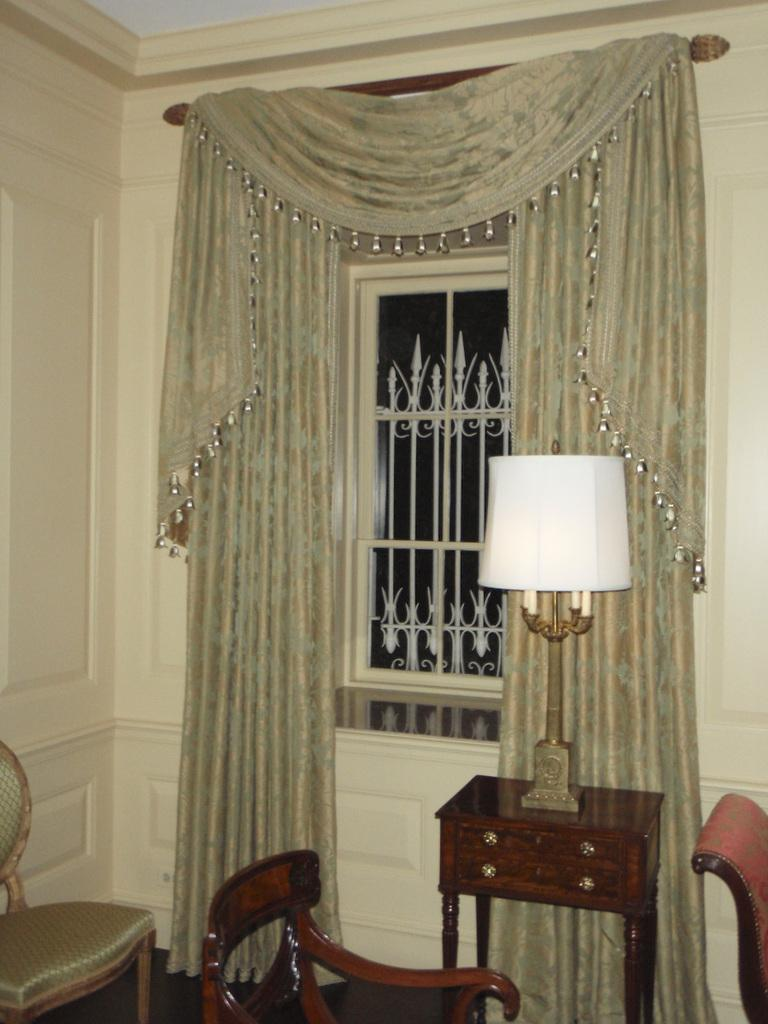What object is on the table in the image? There is a lamp on a table in the image. What type of furniture is present in the image? There are chairs in the image. What is the background of the image composed of? There is a wall in the image, and a window with curtains in the background. What type of beast can be seen roaming around the room in the image? There is no beast present in the image; it only features a lamp on a table, chairs, a wall, and a window with curtains. 